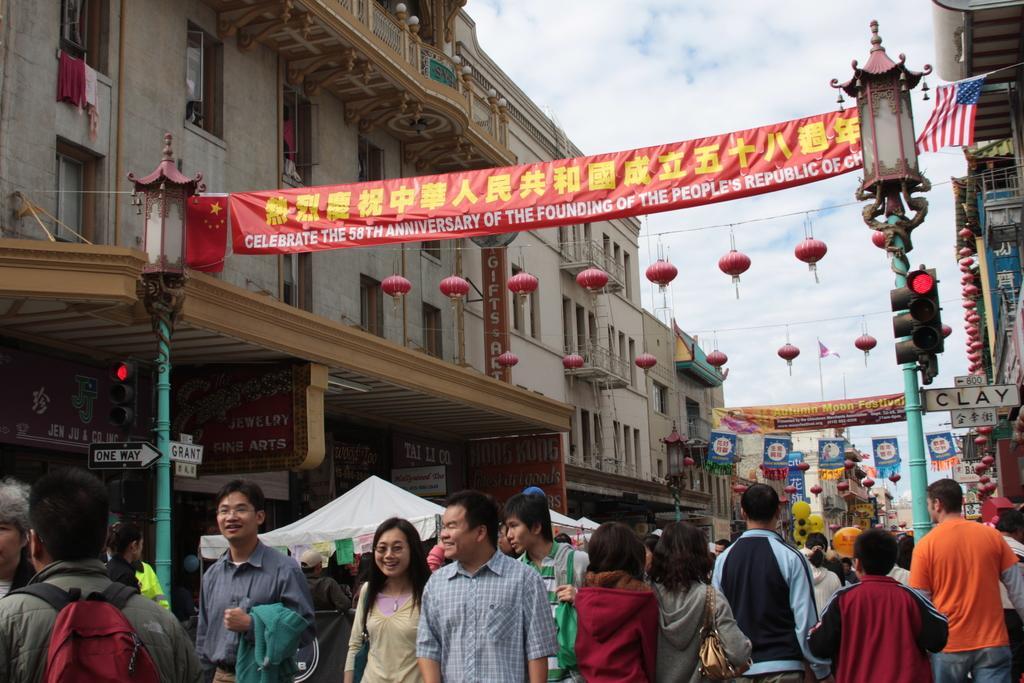Could you give a brief overview of what you see in this image? In this picture we can see a group of people, here we can see tents, electric poles, banners, lights, flag, posters, name boards, buildings and we can see sky in the background. 